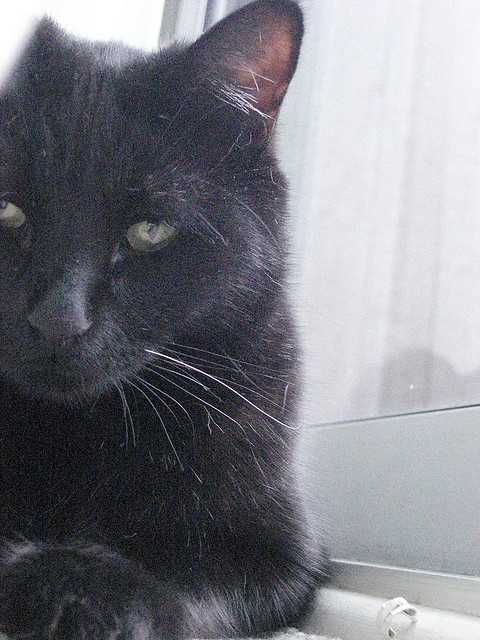Describe the objects in this image and their specific colors. I can see a cat in white, black, gray, and purple tones in this image. 